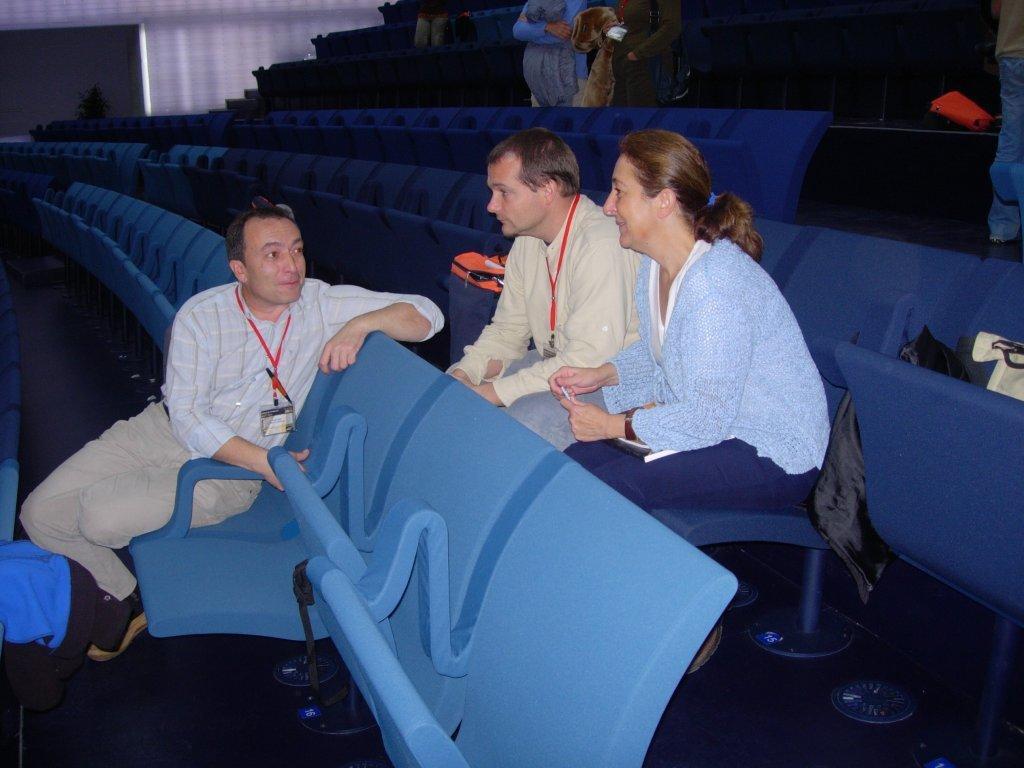Please provide a concise description of this image. In this image I can see few people sitting on the chairs and few people are standing. I can see few objects on the chairs. I can see the white and black color background. 